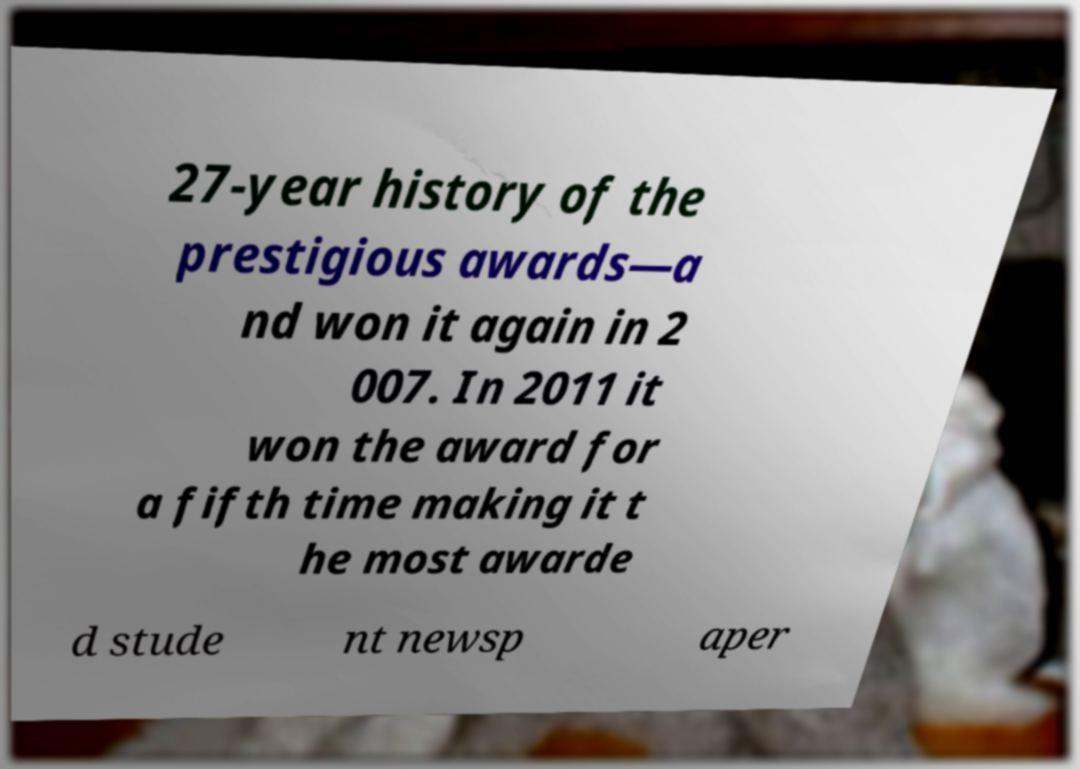Can you read and provide the text displayed in the image?This photo seems to have some interesting text. Can you extract and type it out for me? 27-year history of the prestigious awards—a nd won it again in 2 007. In 2011 it won the award for a fifth time making it t he most awarde d stude nt newsp aper 